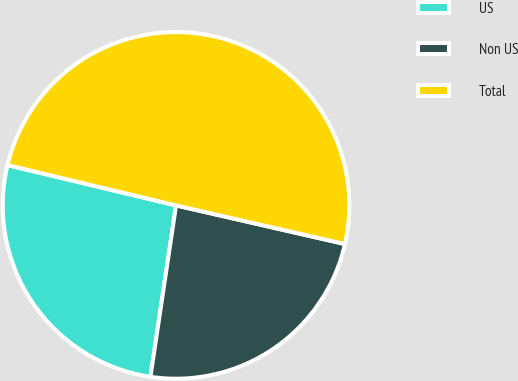<chart> <loc_0><loc_0><loc_500><loc_500><pie_chart><fcel>US<fcel>Non US<fcel>Total<nl><fcel>26.38%<fcel>23.78%<fcel>49.84%<nl></chart> 